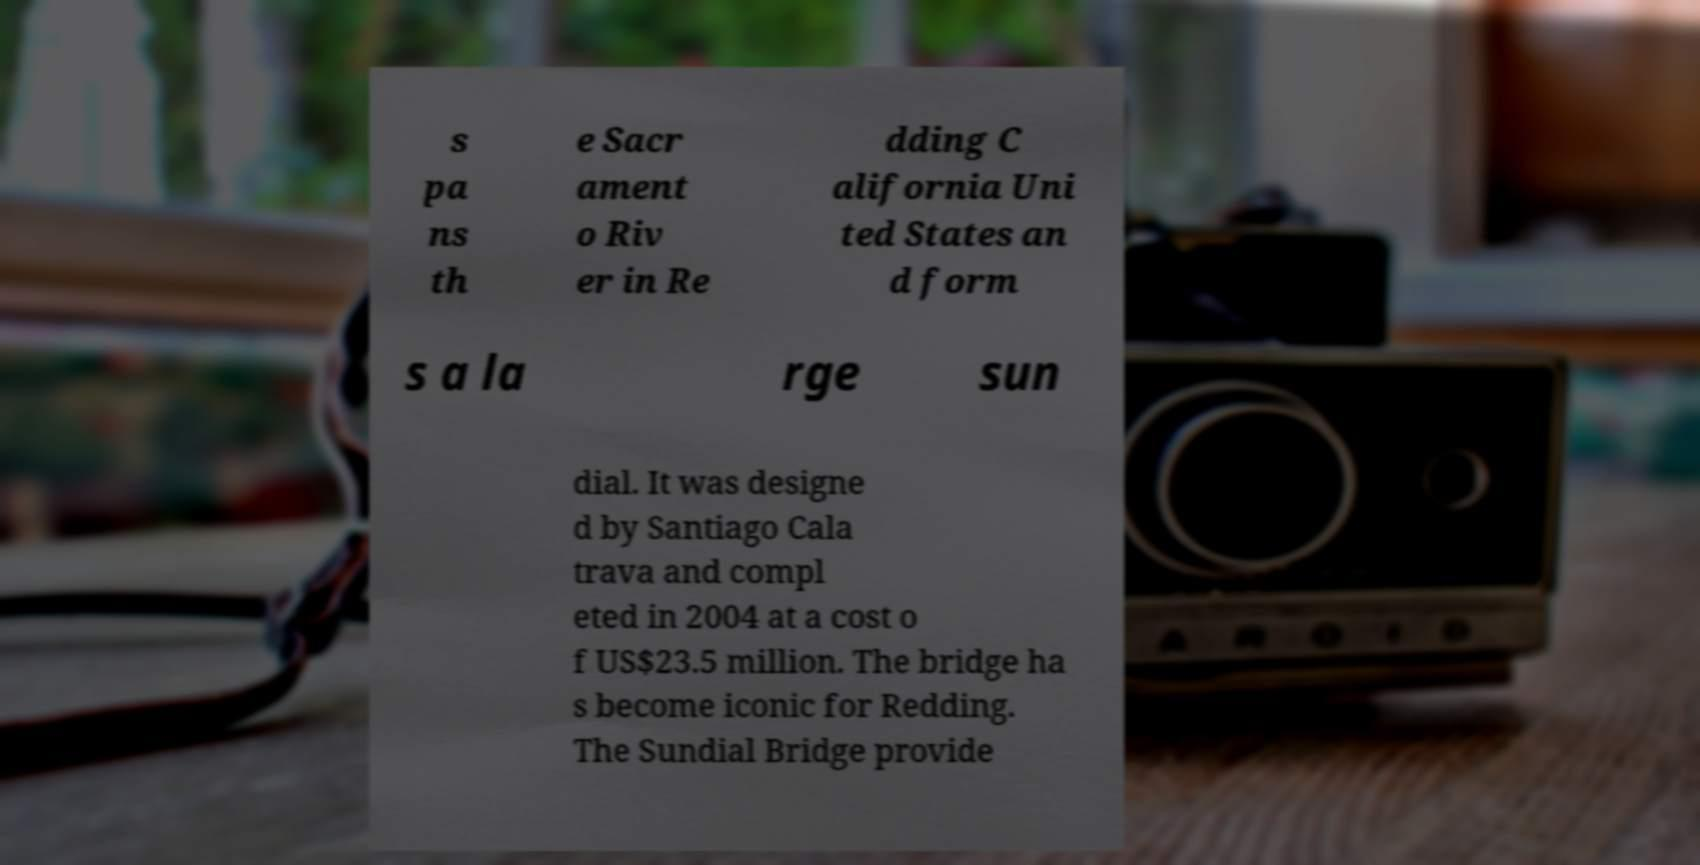I need the written content from this picture converted into text. Can you do that? s pa ns th e Sacr ament o Riv er in Re dding C alifornia Uni ted States an d form s a la rge sun dial. It was designe d by Santiago Cala trava and compl eted in 2004 at a cost o f US$23.5 million. The bridge ha s become iconic for Redding. The Sundial Bridge provide 